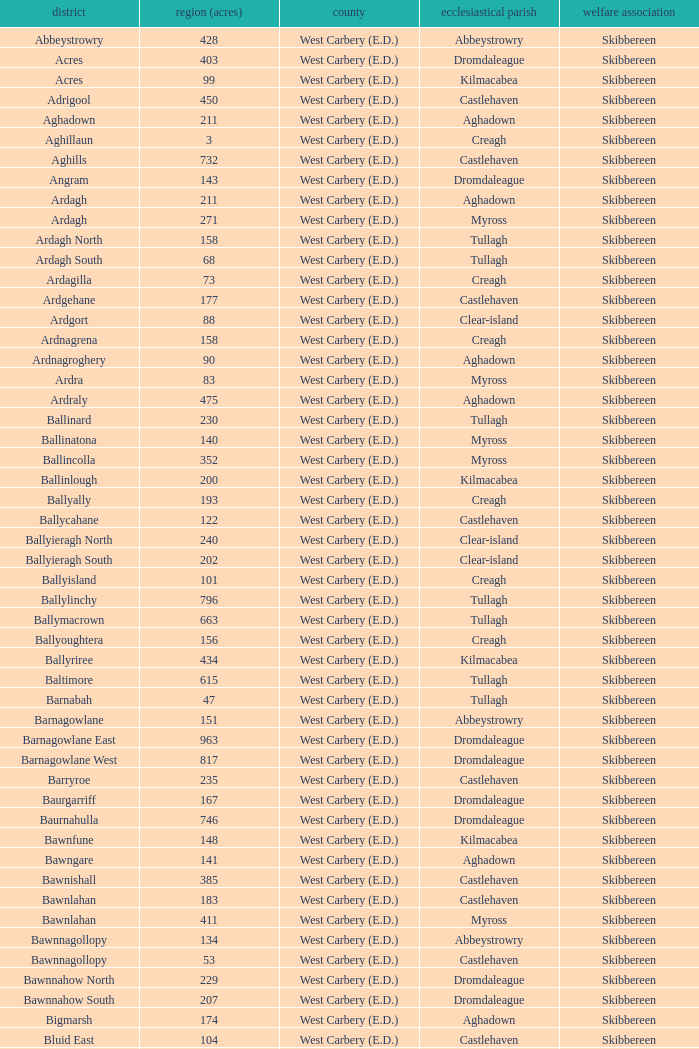What are the civil parishes of the Loughmarsh townland? Aghadown. 